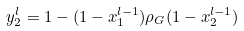Convert formula to latex. <formula><loc_0><loc_0><loc_500><loc_500>y _ { 2 } ^ { l } = 1 - ( 1 - x _ { 1 } ^ { l - 1 } ) \rho _ { G } ( 1 - x _ { 2 } ^ { l - 1 } )</formula> 